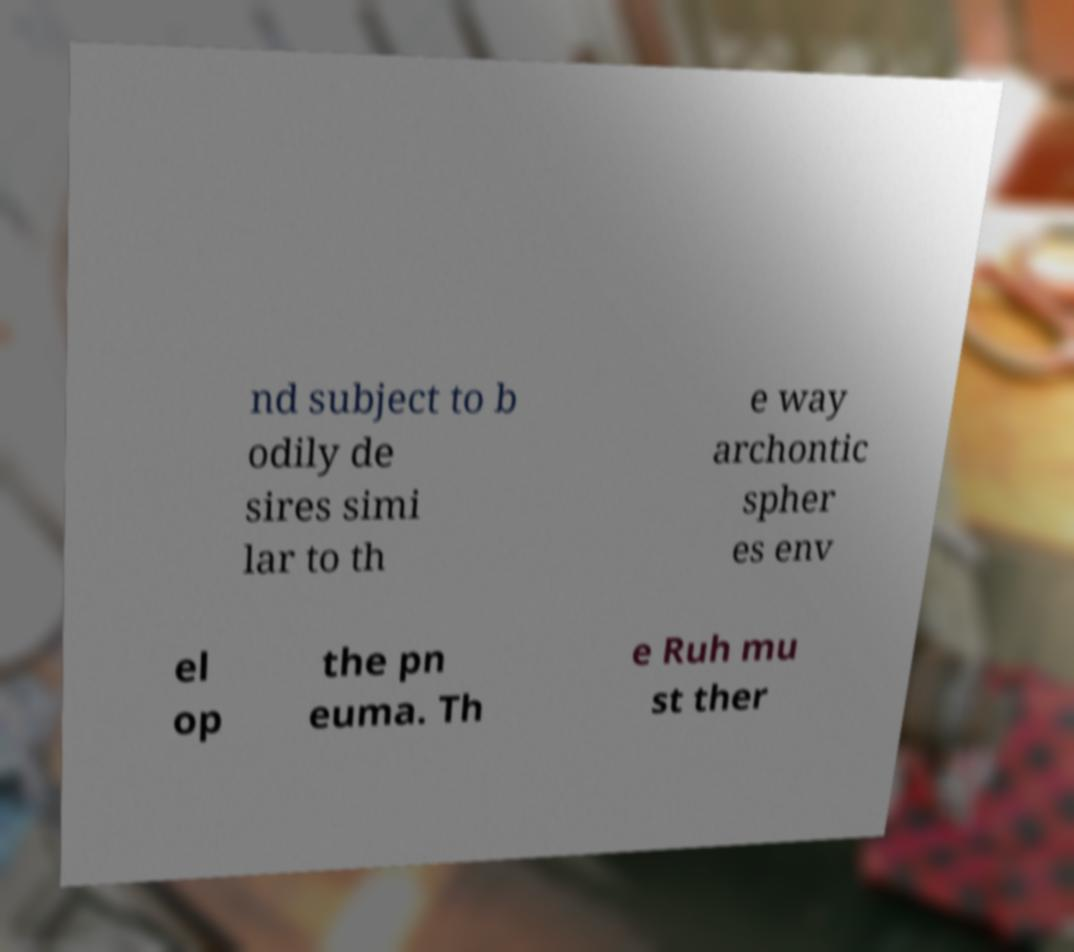Please read and relay the text visible in this image. What does it say? nd subject to b odily de sires simi lar to th e way archontic spher es env el op the pn euma. Th e Ruh mu st ther 